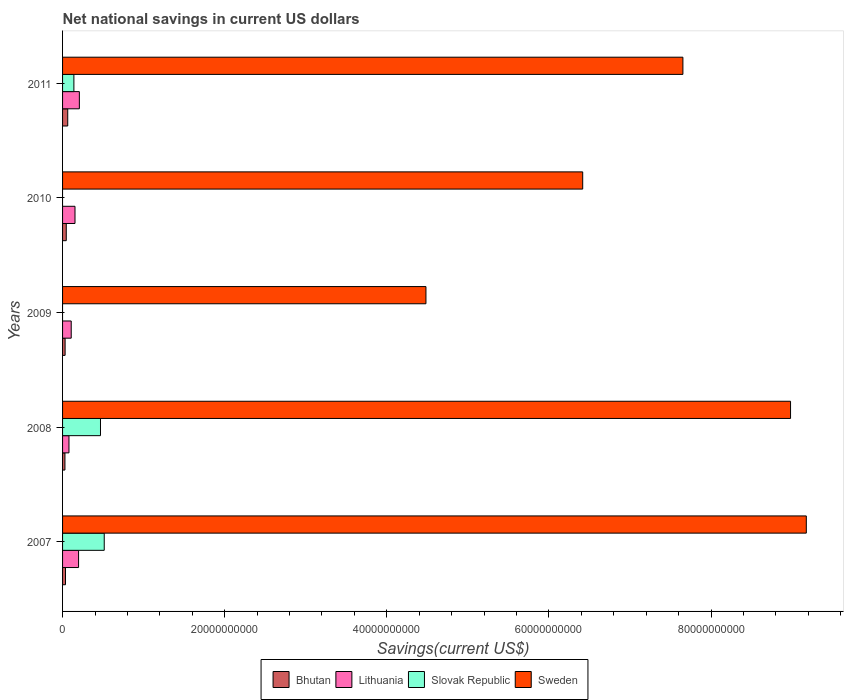How many different coloured bars are there?
Make the answer very short. 4. Are the number of bars per tick equal to the number of legend labels?
Your answer should be very brief. No. Are the number of bars on each tick of the Y-axis equal?
Provide a succinct answer. No. How many bars are there on the 2nd tick from the top?
Give a very brief answer. 3. What is the label of the 3rd group of bars from the top?
Your response must be concise. 2009. In how many cases, is the number of bars for a given year not equal to the number of legend labels?
Give a very brief answer. 2. What is the net national savings in Lithuania in 2008?
Offer a terse response. 7.90e+08. Across all years, what is the maximum net national savings in Bhutan?
Your response must be concise. 6.38e+08. In which year was the net national savings in Slovak Republic maximum?
Provide a short and direct response. 2007. What is the total net national savings in Slovak Republic in the graph?
Offer a very short reply. 1.12e+1. What is the difference between the net national savings in Sweden in 2009 and that in 2011?
Your answer should be compact. -3.17e+1. What is the difference between the net national savings in Slovak Republic in 2010 and the net national savings in Bhutan in 2008?
Your response must be concise. -2.92e+08. What is the average net national savings in Sweden per year?
Offer a very short reply. 7.34e+1. In the year 2008, what is the difference between the net national savings in Bhutan and net national savings in Slovak Republic?
Provide a succinct answer. -4.39e+09. What is the ratio of the net national savings in Lithuania in 2008 to that in 2009?
Provide a short and direct response. 0.74. What is the difference between the highest and the second highest net national savings in Bhutan?
Make the answer very short. 1.82e+08. What is the difference between the highest and the lowest net national savings in Lithuania?
Offer a terse response. 1.28e+09. In how many years, is the net national savings in Lithuania greater than the average net national savings in Lithuania taken over all years?
Your answer should be compact. 3. Is the sum of the net national savings in Lithuania in 2008 and 2009 greater than the maximum net national savings in Sweden across all years?
Provide a short and direct response. No. Is it the case that in every year, the sum of the net national savings in Lithuania and net national savings in Slovak Republic is greater than the sum of net national savings in Sweden and net national savings in Bhutan?
Provide a succinct answer. No. How many bars are there?
Your answer should be compact. 18. Are all the bars in the graph horizontal?
Your answer should be compact. Yes. How many years are there in the graph?
Give a very brief answer. 5. What is the difference between two consecutive major ticks on the X-axis?
Your answer should be compact. 2.00e+1. Are the values on the major ticks of X-axis written in scientific E-notation?
Offer a very short reply. No. Does the graph contain any zero values?
Give a very brief answer. Yes. Does the graph contain grids?
Your response must be concise. No. Where does the legend appear in the graph?
Ensure brevity in your answer.  Bottom center. How many legend labels are there?
Your answer should be very brief. 4. How are the legend labels stacked?
Provide a succinct answer. Horizontal. What is the title of the graph?
Ensure brevity in your answer.  Net national savings in current US dollars. What is the label or title of the X-axis?
Offer a very short reply. Savings(current US$). What is the Savings(current US$) of Bhutan in 2007?
Offer a very short reply. 3.63e+08. What is the Savings(current US$) of Lithuania in 2007?
Keep it short and to the point. 1.98e+09. What is the Savings(current US$) in Slovak Republic in 2007?
Your response must be concise. 5.14e+09. What is the Savings(current US$) of Sweden in 2007?
Your answer should be very brief. 9.17e+1. What is the Savings(current US$) in Bhutan in 2008?
Give a very brief answer. 2.92e+08. What is the Savings(current US$) of Lithuania in 2008?
Offer a terse response. 7.90e+08. What is the Savings(current US$) in Slovak Republic in 2008?
Keep it short and to the point. 4.68e+09. What is the Savings(current US$) of Sweden in 2008?
Keep it short and to the point. 8.98e+1. What is the Savings(current US$) in Bhutan in 2009?
Your answer should be very brief. 3.13e+08. What is the Savings(current US$) of Lithuania in 2009?
Provide a short and direct response. 1.07e+09. What is the Savings(current US$) in Sweden in 2009?
Offer a terse response. 4.48e+1. What is the Savings(current US$) in Bhutan in 2010?
Provide a short and direct response. 4.57e+08. What is the Savings(current US$) of Lithuania in 2010?
Keep it short and to the point. 1.53e+09. What is the Savings(current US$) in Sweden in 2010?
Provide a succinct answer. 6.42e+1. What is the Savings(current US$) of Bhutan in 2011?
Offer a very short reply. 6.38e+08. What is the Savings(current US$) of Lithuania in 2011?
Provide a short and direct response. 2.07e+09. What is the Savings(current US$) of Slovak Republic in 2011?
Your response must be concise. 1.40e+09. What is the Savings(current US$) of Sweden in 2011?
Provide a short and direct response. 7.65e+1. Across all years, what is the maximum Savings(current US$) of Bhutan?
Offer a very short reply. 6.38e+08. Across all years, what is the maximum Savings(current US$) of Lithuania?
Your response must be concise. 2.07e+09. Across all years, what is the maximum Savings(current US$) in Slovak Republic?
Ensure brevity in your answer.  5.14e+09. Across all years, what is the maximum Savings(current US$) in Sweden?
Provide a short and direct response. 9.17e+1. Across all years, what is the minimum Savings(current US$) of Bhutan?
Provide a short and direct response. 2.92e+08. Across all years, what is the minimum Savings(current US$) in Lithuania?
Ensure brevity in your answer.  7.90e+08. Across all years, what is the minimum Savings(current US$) of Sweden?
Ensure brevity in your answer.  4.48e+1. What is the total Savings(current US$) of Bhutan in the graph?
Provide a succinct answer. 2.06e+09. What is the total Savings(current US$) of Lithuania in the graph?
Keep it short and to the point. 7.44e+09. What is the total Savings(current US$) in Slovak Republic in the graph?
Ensure brevity in your answer.  1.12e+1. What is the total Savings(current US$) in Sweden in the graph?
Make the answer very short. 3.67e+11. What is the difference between the Savings(current US$) in Bhutan in 2007 and that in 2008?
Your response must be concise. 7.07e+07. What is the difference between the Savings(current US$) of Lithuania in 2007 and that in 2008?
Make the answer very short. 1.19e+09. What is the difference between the Savings(current US$) in Slovak Republic in 2007 and that in 2008?
Offer a very short reply. 4.62e+08. What is the difference between the Savings(current US$) in Sweden in 2007 and that in 2008?
Ensure brevity in your answer.  1.94e+09. What is the difference between the Savings(current US$) of Bhutan in 2007 and that in 2009?
Keep it short and to the point. 4.99e+07. What is the difference between the Savings(current US$) of Lithuania in 2007 and that in 2009?
Keep it short and to the point. 9.07e+08. What is the difference between the Savings(current US$) of Sweden in 2007 and that in 2009?
Your answer should be compact. 4.69e+1. What is the difference between the Savings(current US$) in Bhutan in 2007 and that in 2010?
Make the answer very short. -9.37e+07. What is the difference between the Savings(current US$) of Lithuania in 2007 and that in 2010?
Offer a terse response. 4.42e+08. What is the difference between the Savings(current US$) in Sweden in 2007 and that in 2010?
Provide a succinct answer. 2.76e+1. What is the difference between the Savings(current US$) in Bhutan in 2007 and that in 2011?
Give a very brief answer. -2.75e+08. What is the difference between the Savings(current US$) of Lithuania in 2007 and that in 2011?
Make the answer very short. -9.66e+07. What is the difference between the Savings(current US$) in Slovak Republic in 2007 and that in 2011?
Make the answer very short. 3.74e+09. What is the difference between the Savings(current US$) in Sweden in 2007 and that in 2011?
Keep it short and to the point. 1.52e+1. What is the difference between the Savings(current US$) of Bhutan in 2008 and that in 2009?
Your response must be concise. -2.08e+07. What is the difference between the Savings(current US$) in Lithuania in 2008 and that in 2009?
Make the answer very short. -2.78e+08. What is the difference between the Savings(current US$) in Sweden in 2008 and that in 2009?
Offer a very short reply. 4.50e+1. What is the difference between the Savings(current US$) in Bhutan in 2008 and that in 2010?
Make the answer very short. -1.64e+08. What is the difference between the Savings(current US$) of Lithuania in 2008 and that in 2010?
Make the answer very short. -7.43e+08. What is the difference between the Savings(current US$) in Sweden in 2008 and that in 2010?
Give a very brief answer. 2.56e+1. What is the difference between the Savings(current US$) of Bhutan in 2008 and that in 2011?
Make the answer very short. -3.46e+08. What is the difference between the Savings(current US$) in Lithuania in 2008 and that in 2011?
Offer a terse response. -1.28e+09. What is the difference between the Savings(current US$) in Slovak Republic in 2008 and that in 2011?
Your response must be concise. 3.28e+09. What is the difference between the Savings(current US$) of Sweden in 2008 and that in 2011?
Your answer should be compact. 1.33e+1. What is the difference between the Savings(current US$) of Bhutan in 2009 and that in 2010?
Keep it short and to the point. -1.44e+08. What is the difference between the Savings(current US$) in Lithuania in 2009 and that in 2010?
Offer a terse response. -4.65e+08. What is the difference between the Savings(current US$) of Sweden in 2009 and that in 2010?
Your response must be concise. -1.93e+1. What is the difference between the Savings(current US$) of Bhutan in 2009 and that in 2011?
Ensure brevity in your answer.  -3.25e+08. What is the difference between the Savings(current US$) in Lithuania in 2009 and that in 2011?
Provide a succinct answer. -1.00e+09. What is the difference between the Savings(current US$) in Sweden in 2009 and that in 2011?
Your answer should be very brief. -3.17e+1. What is the difference between the Savings(current US$) in Bhutan in 2010 and that in 2011?
Offer a terse response. -1.82e+08. What is the difference between the Savings(current US$) of Lithuania in 2010 and that in 2011?
Ensure brevity in your answer.  -5.39e+08. What is the difference between the Savings(current US$) in Sweden in 2010 and that in 2011?
Give a very brief answer. -1.24e+1. What is the difference between the Savings(current US$) in Bhutan in 2007 and the Savings(current US$) in Lithuania in 2008?
Provide a short and direct response. -4.27e+08. What is the difference between the Savings(current US$) in Bhutan in 2007 and the Savings(current US$) in Slovak Republic in 2008?
Offer a very short reply. -4.31e+09. What is the difference between the Savings(current US$) in Bhutan in 2007 and the Savings(current US$) in Sweden in 2008?
Give a very brief answer. -8.94e+1. What is the difference between the Savings(current US$) of Lithuania in 2007 and the Savings(current US$) of Slovak Republic in 2008?
Give a very brief answer. -2.70e+09. What is the difference between the Savings(current US$) in Lithuania in 2007 and the Savings(current US$) in Sweden in 2008?
Make the answer very short. -8.78e+1. What is the difference between the Savings(current US$) of Slovak Republic in 2007 and the Savings(current US$) of Sweden in 2008?
Provide a short and direct response. -8.47e+1. What is the difference between the Savings(current US$) in Bhutan in 2007 and the Savings(current US$) in Lithuania in 2009?
Ensure brevity in your answer.  -7.05e+08. What is the difference between the Savings(current US$) in Bhutan in 2007 and the Savings(current US$) in Sweden in 2009?
Provide a succinct answer. -4.45e+1. What is the difference between the Savings(current US$) in Lithuania in 2007 and the Savings(current US$) in Sweden in 2009?
Make the answer very short. -4.28e+1. What is the difference between the Savings(current US$) of Slovak Republic in 2007 and the Savings(current US$) of Sweden in 2009?
Your answer should be very brief. -3.97e+1. What is the difference between the Savings(current US$) in Bhutan in 2007 and the Savings(current US$) in Lithuania in 2010?
Offer a very short reply. -1.17e+09. What is the difference between the Savings(current US$) of Bhutan in 2007 and the Savings(current US$) of Sweden in 2010?
Give a very brief answer. -6.38e+1. What is the difference between the Savings(current US$) of Lithuania in 2007 and the Savings(current US$) of Sweden in 2010?
Provide a short and direct response. -6.22e+1. What is the difference between the Savings(current US$) of Slovak Republic in 2007 and the Savings(current US$) of Sweden in 2010?
Provide a succinct answer. -5.90e+1. What is the difference between the Savings(current US$) of Bhutan in 2007 and the Savings(current US$) of Lithuania in 2011?
Your answer should be very brief. -1.71e+09. What is the difference between the Savings(current US$) in Bhutan in 2007 and the Savings(current US$) in Slovak Republic in 2011?
Provide a short and direct response. -1.03e+09. What is the difference between the Savings(current US$) in Bhutan in 2007 and the Savings(current US$) in Sweden in 2011?
Make the answer very short. -7.62e+1. What is the difference between the Savings(current US$) of Lithuania in 2007 and the Savings(current US$) of Slovak Republic in 2011?
Your answer should be compact. 5.78e+08. What is the difference between the Savings(current US$) in Lithuania in 2007 and the Savings(current US$) in Sweden in 2011?
Keep it short and to the point. -7.45e+1. What is the difference between the Savings(current US$) in Slovak Republic in 2007 and the Savings(current US$) in Sweden in 2011?
Your answer should be very brief. -7.14e+1. What is the difference between the Savings(current US$) of Bhutan in 2008 and the Savings(current US$) of Lithuania in 2009?
Offer a terse response. -7.76e+08. What is the difference between the Savings(current US$) of Bhutan in 2008 and the Savings(current US$) of Sweden in 2009?
Your response must be concise. -4.45e+1. What is the difference between the Savings(current US$) of Lithuania in 2008 and the Savings(current US$) of Sweden in 2009?
Keep it short and to the point. -4.40e+1. What is the difference between the Savings(current US$) of Slovak Republic in 2008 and the Savings(current US$) of Sweden in 2009?
Offer a terse response. -4.01e+1. What is the difference between the Savings(current US$) in Bhutan in 2008 and the Savings(current US$) in Lithuania in 2010?
Provide a short and direct response. -1.24e+09. What is the difference between the Savings(current US$) in Bhutan in 2008 and the Savings(current US$) in Sweden in 2010?
Provide a short and direct response. -6.39e+1. What is the difference between the Savings(current US$) in Lithuania in 2008 and the Savings(current US$) in Sweden in 2010?
Your answer should be compact. -6.34e+1. What is the difference between the Savings(current US$) in Slovak Republic in 2008 and the Savings(current US$) in Sweden in 2010?
Your answer should be compact. -5.95e+1. What is the difference between the Savings(current US$) of Bhutan in 2008 and the Savings(current US$) of Lithuania in 2011?
Offer a very short reply. -1.78e+09. What is the difference between the Savings(current US$) of Bhutan in 2008 and the Savings(current US$) of Slovak Republic in 2011?
Your answer should be very brief. -1.11e+09. What is the difference between the Savings(current US$) in Bhutan in 2008 and the Savings(current US$) in Sweden in 2011?
Provide a succinct answer. -7.62e+1. What is the difference between the Savings(current US$) in Lithuania in 2008 and the Savings(current US$) in Slovak Republic in 2011?
Provide a short and direct response. -6.08e+08. What is the difference between the Savings(current US$) in Lithuania in 2008 and the Savings(current US$) in Sweden in 2011?
Give a very brief answer. -7.57e+1. What is the difference between the Savings(current US$) of Slovak Republic in 2008 and the Savings(current US$) of Sweden in 2011?
Your answer should be compact. -7.18e+1. What is the difference between the Savings(current US$) of Bhutan in 2009 and the Savings(current US$) of Lithuania in 2010?
Your answer should be very brief. -1.22e+09. What is the difference between the Savings(current US$) in Bhutan in 2009 and the Savings(current US$) in Sweden in 2010?
Provide a succinct answer. -6.38e+1. What is the difference between the Savings(current US$) in Lithuania in 2009 and the Savings(current US$) in Sweden in 2010?
Make the answer very short. -6.31e+1. What is the difference between the Savings(current US$) in Bhutan in 2009 and the Savings(current US$) in Lithuania in 2011?
Your response must be concise. -1.76e+09. What is the difference between the Savings(current US$) in Bhutan in 2009 and the Savings(current US$) in Slovak Republic in 2011?
Make the answer very short. -1.08e+09. What is the difference between the Savings(current US$) in Bhutan in 2009 and the Savings(current US$) in Sweden in 2011?
Your answer should be compact. -7.62e+1. What is the difference between the Savings(current US$) in Lithuania in 2009 and the Savings(current US$) in Slovak Republic in 2011?
Ensure brevity in your answer.  -3.30e+08. What is the difference between the Savings(current US$) of Lithuania in 2009 and the Savings(current US$) of Sweden in 2011?
Provide a succinct answer. -7.55e+1. What is the difference between the Savings(current US$) in Bhutan in 2010 and the Savings(current US$) in Lithuania in 2011?
Keep it short and to the point. -1.62e+09. What is the difference between the Savings(current US$) in Bhutan in 2010 and the Savings(current US$) in Slovak Republic in 2011?
Keep it short and to the point. -9.41e+08. What is the difference between the Savings(current US$) of Bhutan in 2010 and the Savings(current US$) of Sweden in 2011?
Make the answer very short. -7.61e+1. What is the difference between the Savings(current US$) of Lithuania in 2010 and the Savings(current US$) of Slovak Republic in 2011?
Provide a short and direct response. 1.36e+08. What is the difference between the Savings(current US$) in Lithuania in 2010 and the Savings(current US$) in Sweden in 2011?
Your answer should be compact. -7.50e+1. What is the average Savings(current US$) of Bhutan per year?
Provide a short and direct response. 4.13e+08. What is the average Savings(current US$) in Lithuania per year?
Offer a very short reply. 1.49e+09. What is the average Savings(current US$) in Slovak Republic per year?
Keep it short and to the point. 2.24e+09. What is the average Savings(current US$) of Sweden per year?
Provide a short and direct response. 7.34e+1. In the year 2007, what is the difference between the Savings(current US$) of Bhutan and Savings(current US$) of Lithuania?
Your response must be concise. -1.61e+09. In the year 2007, what is the difference between the Savings(current US$) of Bhutan and Savings(current US$) of Slovak Republic?
Keep it short and to the point. -4.78e+09. In the year 2007, what is the difference between the Savings(current US$) of Bhutan and Savings(current US$) of Sweden?
Your answer should be very brief. -9.14e+1. In the year 2007, what is the difference between the Savings(current US$) in Lithuania and Savings(current US$) in Slovak Republic?
Provide a short and direct response. -3.16e+09. In the year 2007, what is the difference between the Savings(current US$) of Lithuania and Savings(current US$) of Sweden?
Your answer should be very brief. -8.98e+1. In the year 2007, what is the difference between the Savings(current US$) of Slovak Republic and Savings(current US$) of Sweden?
Your response must be concise. -8.66e+1. In the year 2008, what is the difference between the Savings(current US$) of Bhutan and Savings(current US$) of Lithuania?
Provide a short and direct response. -4.98e+08. In the year 2008, what is the difference between the Savings(current US$) of Bhutan and Savings(current US$) of Slovak Republic?
Give a very brief answer. -4.39e+09. In the year 2008, what is the difference between the Savings(current US$) of Bhutan and Savings(current US$) of Sweden?
Ensure brevity in your answer.  -8.95e+1. In the year 2008, what is the difference between the Savings(current US$) in Lithuania and Savings(current US$) in Slovak Republic?
Offer a very short reply. -3.89e+09. In the year 2008, what is the difference between the Savings(current US$) of Lithuania and Savings(current US$) of Sweden?
Your answer should be very brief. -8.90e+1. In the year 2008, what is the difference between the Savings(current US$) in Slovak Republic and Savings(current US$) in Sweden?
Your response must be concise. -8.51e+1. In the year 2009, what is the difference between the Savings(current US$) of Bhutan and Savings(current US$) of Lithuania?
Offer a terse response. -7.55e+08. In the year 2009, what is the difference between the Savings(current US$) of Bhutan and Savings(current US$) of Sweden?
Provide a succinct answer. -4.45e+1. In the year 2009, what is the difference between the Savings(current US$) of Lithuania and Savings(current US$) of Sweden?
Offer a very short reply. -4.38e+1. In the year 2010, what is the difference between the Savings(current US$) in Bhutan and Savings(current US$) in Lithuania?
Give a very brief answer. -1.08e+09. In the year 2010, what is the difference between the Savings(current US$) in Bhutan and Savings(current US$) in Sweden?
Keep it short and to the point. -6.37e+1. In the year 2010, what is the difference between the Savings(current US$) in Lithuania and Savings(current US$) in Sweden?
Your answer should be compact. -6.26e+1. In the year 2011, what is the difference between the Savings(current US$) in Bhutan and Savings(current US$) in Lithuania?
Offer a terse response. -1.43e+09. In the year 2011, what is the difference between the Savings(current US$) in Bhutan and Savings(current US$) in Slovak Republic?
Provide a succinct answer. -7.60e+08. In the year 2011, what is the difference between the Savings(current US$) of Bhutan and Savings(current US$) of Sweden?
Offer a terse response. -7.59e+1. In the year 2011, what is the difference between the Savings(current US$) in Lithuania and Savings(current US$) in Slovak Republic?
Ensure brevity in your answer.  6.74e+08. In the year 2011, what is the difference between the Savings(current US$) of Lithuania and Savings(current US$) of Sweden?
Keep it short and to the point. -7.44e+1. In the year 2011, what is the difference between the Savings(current US$) of Slovak Republic and Savings(current US$) of Sweden?
Make the answer very short. -7.51e+1. What is the ratio of the Savings(current US$) in Bhutan in 2007 to that in 2008?
Offer a very short reply. 1.24. What is the ratio of the Savings(current US$) of Lithuania in 2007 to that in 2008?
Offer a terse response. 2.5. What is the ratio of the Savings(current US$) in Slovak Republic in 2007 to that in 2008?
Make the answer very short. 1.1. What is the ratio of the Savings(current US$) of Sweden in 2007 to that in 2008?
Keep it short and to the point. 1.02. What is the ratio of the Savings(current US$) of Bhutan in 2007 to that in 2009?
Offer a very short reply. 1.16. What is the ratio of the Savings(current US$) in Lithuania in 2007 to that in 2009?
Keep it short and to the point. 1.85. What is the ratio of the Savings(current US$) of Sweden in 2007 to that in 2009?
Provide a succinct answer. 2.05. What is the ratio of the Savings(current US$) of Bhutan in 2007 to that in 2010?
Your response must be concise. 0.79. What is the ratio of the Savings(current US$) in Lithuania in 2007 to that in 2010?
Ensure brevity in your answer.  1.29. What is the ratio of the Savings(current US$) of Sweden in 2007 to that in 2010?
Provide a short and direct response. 1.43. What is the ratio of the Savings(current US$) in Bhutan in 2007 to that in 2011?
Provide a short and direct response. 0.57. What is the ratio of the Savings(current US$) of Lithuania in 2007 to that in 2011?
Your answer should be compact. 0.95. What is the ratio of the Savings(current US$) of Slovak Republic in 2007 to that in 2011?
Your response must be concise. 3.68. What is the ratio of the Savings(current US$) in Sweden in 2007 to that in 2011?
Offer a terse response. 1.2. What is the ratio of the Savings(current US$) in Bhutan in 2008 to that in 2009?
Offer a terse response. 0.93. What is the ratio of the Savings(current US$) of Lithuania in 2008 to that in 2009?
Make the answer very short. 0.74. What is the ratio of the Savings(current US$) in Sweden in 2008 to that in 2009?
Provide a succinct answer. 2. What is the ratio of the Savings(current US$) in Bhutan in 2008 to that in 2010?
Offer a terse response. 0.64. What is the ratio of the Savings(current US$) of Lithuania in 2008 to that in 2010?
Make the answer very short. 0.52. What is the ratio of the Savings(current US$) in Sweden in 2008 to that in 2010?
Make the answer very short. 1.4. What is the ratio of the Savings(current US$) of Bhutan in 2008 to that in 2011?
Provide a succinct answer. 0.46. What is the ratio of the Savings(current US$) of Lithuania in 2008 to that in 2011?
Offer a terse response. 0.38. What is the ratio of the Savings(current US$) of Slovak Republic in 2008 to that in 2011?
Ensure brevity in your answer.  3.35. What is the ratio of the Savings(current US$) in Sweden in 2008 to that in 2011?
Offer a terse response. 1.17. What is the ratio of the Savings(current US$) in Bhutan in 2009 to that in 2010?
Provide a short and direct response. 0.69. What is the ratio of the Savings(current US$) of Lithuania in 2009 to that in 2010?
Offer a very short reply. 0.7. What is the ratio of the Savings(current US$) in Sweden in 2009 to that in 2010?
Keep it short and to the point. 0.7. What is the ratio of the Savings(current US$) in Bhutan in 2009 to that in 2011?
Offer a terse response. 0.49. What is the ratio of the Savings(current US$) of Lithuania in 2009 to that in 2011?
Your answer should be compact. 0.52. What is the ratio of the Savings(current US$) of Sweden in 2009 to that in 2011?
Your answer should be very brief. 0.59. What is the ratio of the Savings(current US$) of Bhutan in 2010 to that in 2011?
Your answer should be compact. 0.72. What is the ratio of the Savings(current US$) in Lithuania in 2010 to that in 2011?
Provide a short and direct response. 0.74. What is the ratio of the Savings(current US$) in Sweden in 2010 to that in 2011?
Make the answer very short. 0.84. What is the difference between the highest and the second highest Savings(current US$) in Bhutan?
Provide a short and direct response. 1.82e+08. What is the difference between the highest and the second highest Savings(current US$) of Lithuania?
Provide a succinct answer. 9.66e+07. What is the difference between the highest and the second highest Savings(current US$) of Slovak Republic?
Ensure brevity in your answer.  4.62e+08. What is the difference between the highest and the second highest Savings(current US$) in Sweden?
Your response must be concise. 1.94e+09. What is the difference between the highest and the lowest Savings(current US$) in Bhutan?
Your response must be concise. 3.46e+08. What is the difference between the highest and the lowest Savings(current US$) of Lithuania?
Make the answer very short. 1.28e+09. What is the difference between the highest and the lowest Savings(current US$) in Slovak Republic?
Keep it short and to the point. 5.14e+09. What is the difference between the highest and the lowest Savings(current US$) in Sweden?
Give a very brief answer. 4.69e+1. 